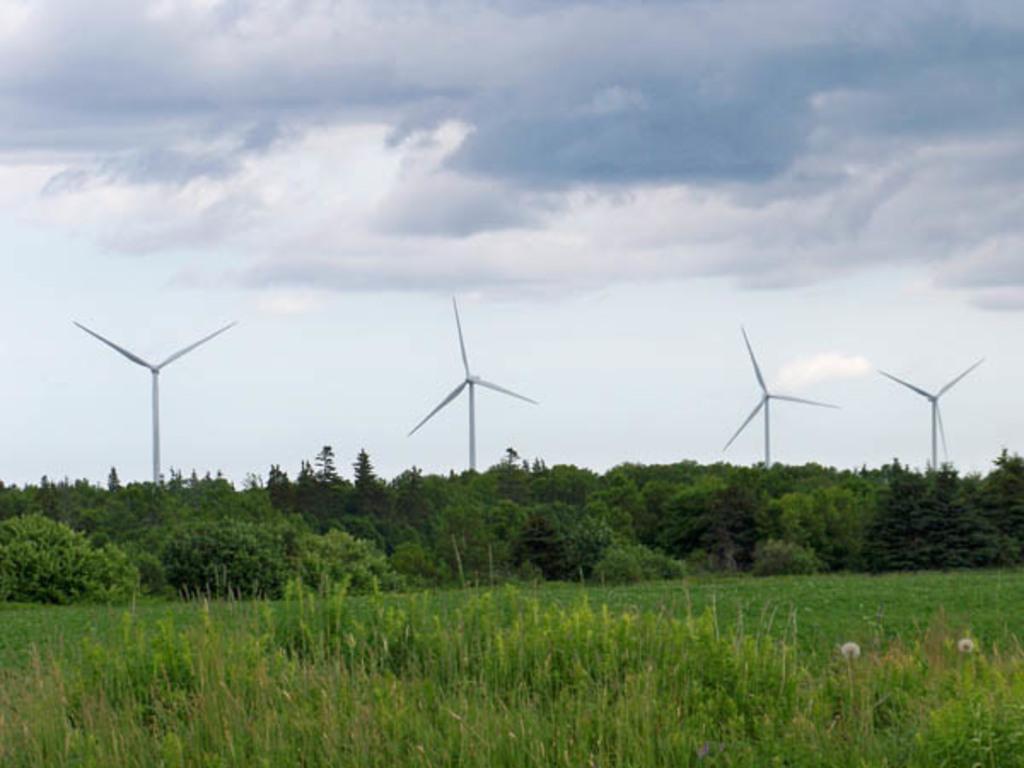Please provide a concise description of this image. In this picture we can see plants at the bottom, in the background there are some trees, we can see four wind turbines in the background, there is the sky and clouds at the top of the picture. 